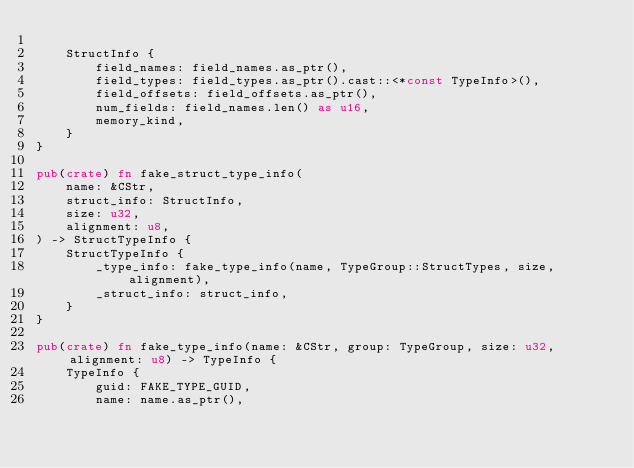Convert code to text. <code><loc_0><loc_0><loc_500><loc_500><_Rust_>
    StructInfo {
        field_names: field_names.as_ptr(),
        field_types: field_types.as_ptr().cast::<*const TypeInfo>(),
        field_offsets: field_offsets.as_ptr(),
        num_fields: field_names.len() as u16,
        memory_kind,
    }
}

pub(crate) fn fake_struct_type_info(
    name: &CStr,
    struct_info: StructInfo,
    size: u32,
    alignment: u8,
) -> StructTypeInfo {
    StructTypeInfo {
        _type_info: fake_type_info(name, TypeGroup::StructTypes, size, alignment),
        _struct_info: struct_info,
    }
}

pub(crate) fn fake_type_info(name: &CStr, group: TypeGroup, size: u32, alignment: u8) -> TypeInfo {
    TypeInfo {
        guid: FAKE_TYPE_GUID,
        name: name.as_ptr(),</code> 